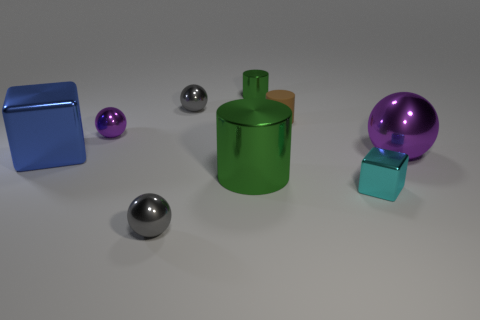The big metallic thing that is right of the small cylinder behind the tiny brown cylinder is what shape?
Provide a short and direct response. Sphere. There is a green shiny thing behind the small gray thing that is behind the small gray metallic thing that is in front of the large metal cylinder; what shape is it?
Offer a terse response. Cylinder. What number of tiny things have the same shape as the big purple object?
Your answer should be very brief. 3. There is a thing on the right side of the small cyan cube; how many blue metal objects are in front of it?
Ensure brevity in your answer.  0. How many matte objects are either small cubes or tiny objects?
Ensure brevity in your answer.  1. Is there a small cube made of the same material as the big cube?
Give a very brief answer. Yes. How many objects are either tiny things that are in front of the big blue thing or matte things that are behind the small cyan metallic thing?
Provide a short and direct response. 3. Do the big metallic object that is to the right of the big green shiny object and the small shiny cylinder have the same color?
Offer a very short reply. No. What number of other objects are there of the same color as the big metal block?
Keep it short and to the point. 0. What is the material of the small cyan cube?
Give a very brief answer. Metal. 